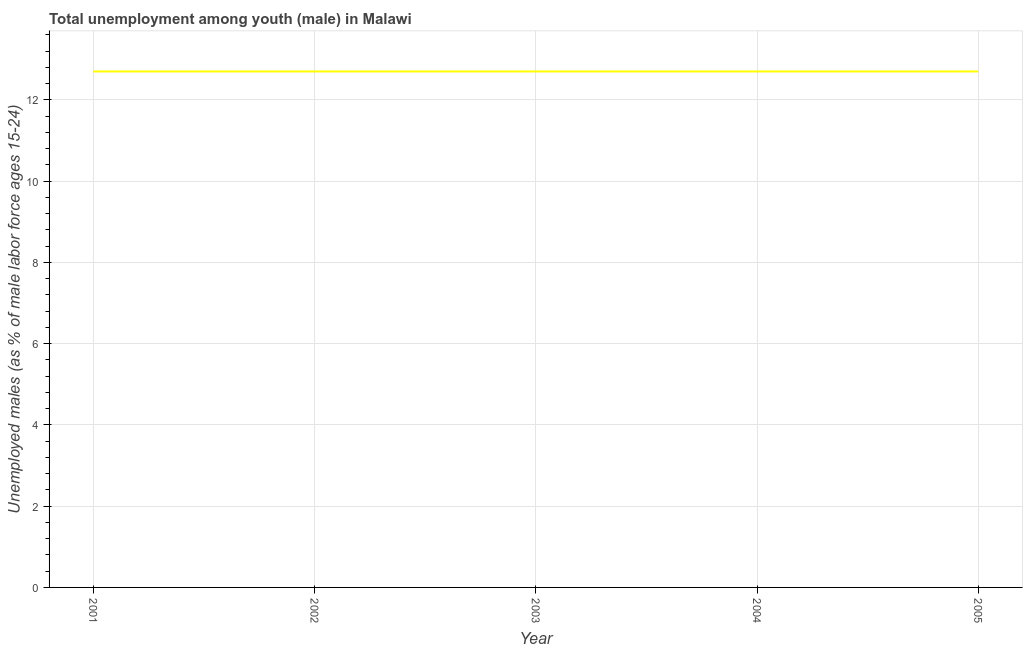What is the unemployed male youth population in 2004?
Offer a very short reply. 12.7. Across all years, what is the maximum unemployed male youth population?
Offer a very short reply. 12.7. Across all years, what is the minimum unemployed male youth population?
Make the answer very short. 12.7. In which year was the unemployed male youth population maximum?
Offer a terse response. 2001. In which year was the unemployed male youth population minimum?
Offer a very short reply. 2001. What is the sum of the unemployed male youth population?
Your response must be concise. 63.5. What is the average unemployed male youth population per year?
Your answer should be very brief. 12.7. What is the median unemployed male youth population?
Offer a very short reply. 12.7. In how many years, is the unemployed male youth population greater than 8 %?
Give a very brief answer. 5. Do a majority of the years between 2003 and 2005 (inclusive) have unemployed male youth population greater than 8.4 %?
Make the answer very short. Yes. What is the ratio of the unemployed male youth population in 2004 to that in 2005?
Your answer should be very brief. 1. Is the unemployed male youth population in 2002 less than that in 2004?
Give a very brief answer. No. Is the difference between the unemployed male youth population in 2002 and 2003 greater than the difference between any two years?
Provide a short and direct response. Yes. Is the sum of the unemployed male youth population in 2003 and 2004 greater than the maximum unemployed male youth population across all years?
Offer a very short reply. Yes. What is the difference between the highest and the lowest unemployed male youth population?
Make the answer very short. 0. Does the unemployed male youth population monotonically increase over the years?
Your answer should be compact. No. Does the graph contain any zero values?
Your response must be concise. No. Does the graph contain grids?
Your answer should be very brief. Yes. What is the title of the graph?
Offer a very short reply. Total unemployment among youth (male) in Malawi. What is the label or title of the Y-axis?
Your response must be concise. Unemployed males (as % of male labor force ages 15-24). What is the Unemployed males (as % of male labor force ages 15-24) in 2001?
Offer a terse response. 12.7. What is the Unemployed males (as % of male labor force ages 15-24) in 2002?
Ensure brevity in your answer.  12.7. What is the Unemployed males (as % of male labor force ages 15-24) in 2003?
Offer a very short reply. 12.7. What is the Unemployed males (as % of male labor force ages 15-24) in 2004?
Make the answer very short. 12.7. What is the Unemployed males (as % of male labor force ages 15-24) of 2005?
Keep it short and to the point. 12.7. What is the difference between the Unemployed males (as % of male labor force ages 15-24) in 2001 and 2003?
Offer a terse response. 0. What is the difference between the Unemployed males (as % of male labor force ages 15-24) in 2001 and 2004?
Keep it short and to the point. 0. What is the difference between the Unemployed males (as % of male labor force ages 15-24) in 2001 and 2005?
Your response must be concise. 0. What is the difference between the Unemployed males (as % of male labor force ages 15-24) in 2002 and 2003?
Keep it short and to the point. 0. What is the difference between the Unemployed males (as % of male labor force ages 15-24) in 2002 and 2005?
Provide a succinct answer. 0. What is the difference between the Unemployed males (as % of male labor force ages 15-24) in 2003 and 2004?
Your answer should be compact. 0. What is the difference between the Unemployed males (as % of male labor force ages 15-24) in 2003 and 2005?
Keep it short and to the point. 0. What is the difference between the Unemployed males (as % of male labor force ages 15-24) in 2004 and 2005?
Provide a short and direct response. 0. What is the ratio of the Unemployed males (as % of male labor force ages 15-24) in 2001 to that in 2002?
Offer a very short reply. 1. What is the ratio of the Unemployed males (as % of male labor force ages 15-24) in 2001 to that in 2003?
Make the answer very short. 1. What is the ratio of the Unemployed males (as % of male labor force ages 15-24) in 2003 to that in 2004?
Ensure brevity in your answer.  1. What is the ratio of the Unemployed males (as % of male labor force ages 15-24) in 2003 to that in 2005?
Make the answer very short. 1. 